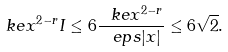<formula> <loc_0><loc_0><loc_500><loc_500>\ k e x ^ { 2 - r } I \leq 6 \frac { \ k e x ^ { 2 - r } } { \ e p s | x | } \leq 6 \sqrt { 2 } .</formula> 